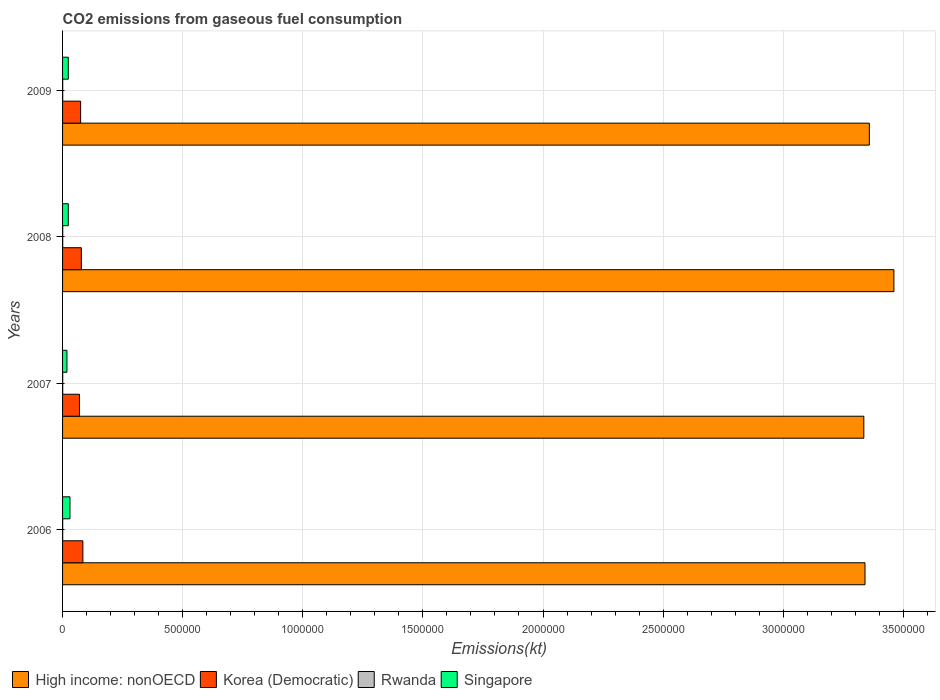How many groups of bars are there?
Keep it short and to the point. 4. Are the number of bars per tick equal to the number of legend labels?
Offer a terse response. Yes. Are the number of bars on each tick of the Y-axis equal?
Ensure brevity in your answer.  Yes. How many bars are there on the 2nd tick from the bottom?
Offer a very short reply. 4. What is the label of the 2nd group of bars from the top?
Your response must be concise. 2008. In how many cases, is the number of bars for a given year not equal to the number of legend labels?
Offer a very short reply. 0. What is the amount of CO2 emitted in Korea (Democratic) in 2006?
Offer a very short reply. 8.46e+04. Across all years, what is the maximum amount of CO2 emitted in Korea (Democratic)?
Offer a terse response. 8.46e+04. Across all years, what is the minimum amount of CO2 emitted in High income: nonOECD?
Offer a terse response. 3.34e+06. In which year was the amount of CO2 emitted in High income: nonOECD maximum?
Keep it short and to the point. 2008. In which year was the amount of CO2 emitted in Korea (Democratic) minimum?
Keep it short and to the point. 2007. What is the total amount of CO2 emitted in Korea (Democratic) in the graph?
Provide a short and direct response. 3.08e+05. What is the difference between the amount of CO2 emitted in High income: nonOECD in 2006 and that in 2008?
Your answer should be very brief. -1.20e+05. What is the difference between the amount of CO2 emitted in Rwanda in 2009 and the amount of CO2 emitted in High income: nonOECD in 2007?
Your response must be concise. -3.34e+06. What is the average amount of CO2 emitted in High income: nonOECD per year?
Your answer should be very brief. 3.37e+06. In the year 2009, what is the difference between the amount of CO2 emitted in Korea (Democratic) and amount of CO2 emitted in Rwanda?
Ensure brevity in your answer.  7.47e+04. In how many years, is the amount of CO2 emitted in Singapore greater than 1500000 kt?
Your answer should be very brief. 0. What is the ratio of the amount of CO2 emitted in High income: nonOECD in 2007 to that in 2008?
Offer a terse response. 0.96. Is the amount of CO2 emitted in Korea (Democratic) in 2008 less than that in 2009?
Provide a short and direct response. No. Is the difference between the amount of CO2 emitted in Korea (Democratic) in 2007 and 2009 greater than the difference between the amount of CO2 emitted in Rwanda in 2007 and 2009?
Your response must be concise. No. What is the difference between the highest and the second highest amount of CO2 emitted in Singapore?
Keep it short and to the point. 6952.63. What is the difference between the highest and the lowest amount of CO2 emitted in Rwanda?
Keep it short and to the point. 47.67. Is it the case that in every year, the sum of the amount of CO2 emitted in Singapore and amount of CO2 emitted in Rwanda is greater than the sum of amount of CO2 emitted in High income: nonOECD and amount of CO2 emitted in Korea (Democratic)?
Provide a succinct answer. Yes. What does the 2nd bar from the top in 2009 represents?
Your response must be concise. Rwanda. What does the 2nd bar from the bottom in 2007 represents?
Make the answer very short. Korea (Democratic). Is it the case that in every year, the sum of the amount of CO2 emitted in Rwanda and amount of CO2 emitted in Korea (Democratic) is greater than the amount of CO2 emitted in Singapore?
Offer a very short reply. Yes. How many bars are there?
Ensure brevity in your answer.  16. Are all the bars in the graph horizontal?
Your answer should be very brief. Yes. How many years are there in the graph?
Offer a terse response. 4. What is the difference between two consecutive major ticks on the X-axis?
Offer a very short reply. 5.00e+05. Are the values on the major ticks of X-axis written in scientific E-notation?
Offer a very short reply. No. Does the graph contain any zero values?
Ensure brevity in your answer.  No. Does the graph contain grids?
Provide a succinct answer. Yes. Where does the legend appear in the graph?
Provide a short and direct response. Bottom left. What is the title of the graph?
Your answer should be compact. CO2 emissions from gaseous fuel consumption. What is the label or title of the X-axis?
Provide a short and direct response. Emissions(kt). What is the label or title of the Y-axis?
Your response must be concise. Years. What is the Emissions(kt) of High income: nonOECD in 2006?
Your response must be concise. 3.34e+06. What is the Emissions(kt) of Korea (Democratic) in 2006?
Your response must be concise. 8.46e+04. What is the Emissions(kt) in Rwanda in 2006?
Provide a short and direct response. 528.05. What is the Emissions(kt) in Singapore in 2006?
Your answer should be very brief. 3.08e+04. What is the Emissions(kt) in High income: nonOECD in 2007?
Offer a very short reply. 3.34e+06. What is the Emissions(kt) of Korea (Democratic) in 2007?
Make the answer very short. 7.04e+04. What is the Emissions(kt) of Rwanda in 2007?
Offer a terse response. 557.38. What is the Emissions(kt) of Singapore in 2007?
Offer a terse response. 1.82e+04. What is the Emissions(kt) in High income: nonOECD in 2008?
Provide a succinct answer. 3.46e+06. What is the Emissions(kt) of Korea (Democratic) in 2008?
Your response must be concise. 7.81e+04. What is the Emissions(kt) in Rwanda in 2008?
Offer a very short reply. 542.72. What is the Emissions(kt) of Singapore in 2008?
Offer a very short reply. 2.38e+04. What is the Emissions(kt) in High income: nonOECD in 2009?
Your answer should be very brief. 3.36e+06. What is the Emissions(kt) of Korea (Democratic) in 2009?
Your answer should be very brief. 7.52e+04. What is the Emissions(kt) of Rwanda in 2009?
Give a very brief answer. 575.72. What is the Emissions(kt) of Singapore in 2009?
Provide a short and direct response. 2.38e+04. Across all years, what is the maximum Emissions(kt) of High income: nonOECD?
Offer a very short reply. 3.46e+06. Across all years, what is the maximum Emissions(kt) of Korea (Democratic)?
Ensure brevity in your answer.  8.46e+04. Across all years, what is the maximum Emissions(kt) in Rwanda?
Make the answer very short. 575.72. Across all years, what is the maximum Emissions(kt) of Singapore?
Give a very brief answer. 3.08e+04. Across all years, what is the minimum Emissions(kt) in High income: nonOECD?
Keep it short and to the point. 3.34e+06. Across all years, what is the minimum Emissions(kt) of Korea (Democratic)?
Keep it short and to the point. 7.04e+04. Across all years, what is the minimum Emissions(kt) of Rwanda?
Ensure brevity in your answer.  528.05. Across all years, what is the minimum Emissions(kt) in Singapore?
Provide a succinct answer. 1.82e+04. What is the total Emissions(kt) in High income: nonOECD in the graph?
Provide a succinct answer. 1.35e+07. What is the total Emissions(kt) in Korea (Democratic) in the graph?
Your answer should be very brief. 3.08e+05. What is the total Emissions(kt) of Rwanda in the graph?
Offer a very short reply. 2203.87. What is the total Emissions(kt) of Singapore in the graph?
Your answer should be compact. 9.67e+04. What is the difference between the Emissions(kt) in High income: nonOECD in 2006 and that in 2007?
Make the answer very short. 4914.35. What is the difference between the Emissions(kt) of Korea (Democratic) in 2006 and that in 2007?
Keep it short and to the point. 1.42e+04. What is the difference between the Emissions(kt) in Rwanda in 2006 and that in 2007?
Your answer should be compact. -29.34. What is the difference between the Emissions(kt) in Singapore in 2006 and that in 2007?
Make the answer very short. 1.26e+04. What is the difference between the Emissions(kt) in High income: nonOECD in 2006 and that in 2008?
Your answer should be compact. -1.20e+05. What is the difference between the Emissions(kt) of Korea (Democratic) in 2006 and that in 2008?
Your answer should be very brief. 6475.92. What is the difference between the Emissions(kt) in Rwanda in 2006 and that in 2008?
Provide a succinct answer. -14.67. What is the difference between the Emissions(kt) in Singapore in 2006 and that in 2008?
Keep it short and to the point. 6952.63. What is the difference between the Emissions(kt) of High income: nonOECD in 2006 and that in 2009?
Provide a short and direct response. -1.81e+04. What is the difference between the Emissions(kt) in Korea (Democratic) in 2006 and that in 2009?
Your answer should be compact. 9328.85. What is the difference between the Emissions(kt) in Rwanda in 2006 and that in 2009?
Provide a short and direct response. -47.67. What is the difference between the Emissions(kt) of Singapore in 2006 and that in 2009?
Ensure brevity in your answer.  6967.3. What is the difference between the Emissions(kt) of High income: nonOECD in 2007 and that in 2008?
Provide a short and direct response. -1.25e+05. What is the difference between the Emissions(kt) of Korea (Democratic) in 2007 and that in 2008?
Provide a succinct answer. -7711.7. What is the difference between the Emissions(kt) in Rwanda in 2007 and that in 2008?
Offer a terse response. 14.67. What is the difference between the Emissions(kt) of Singapore in 2007 and that in 2008?
Provide a short and direct response. -5650.85. What is the difference between the Emissions(kt) in High income: nonOECD in 2007 and that in 2009?
Offer a terse response. -2.30e+04. What is the difference between the Emissions(kt) in Korea (Democratic) in 2007 and that in 2009?
Your answer should be very brief. -4858.77. What is the difference between the Emissions(kt) of Rwanda in 2007 and that in 2009?
Provide a succinct answer. -18.34. What is the difference between the Emissions(kt) of Singapore in 2007 and that in 2009?
Offer a terse response. -5636.18. What is the difference between the Emissions(kt) in High income: nonOECD in 2008 and that in 2009?
Your answer should be compact. 1.02e+05. What is the difference between the Emissions(kt) in Korea (Democratic) in 2008 and that in 2009?
Make the answer very short. 2852.93. What is the difference between the Emissions(kt) of Rwanda in 2008 and that in 2009?
Your response must be concise. -33. What is the difference between the Emissions(kt) of Singapore in 2008 and that in 2009?
Your answer should be very brief. 14.67. What is the difference between the Emissions(kt) of High income: nonOECD in 2006 and the Emissions(kt) of Korea (Democratic) in 2007?
Offer a very short reply. 3.27e+06. What is the difference between the Emissions(kt) of High income: nonOECD in 2006 and the Emissions(kt) of Rwanda in 2007?
Offer a terse response. 3.34e+06. What is the difference between the Emissions(kt) in High income: nonOECD in 2006 and the Emissions(kt) in Singapore in 2007?
Keep it short and to the point. 3.32e+06. What is the difference between the Emissions(kt) of Korea (Democratic) in 2006 and the Emissions(kt) of Rwanda in 2007?
Provide a short and direct response. 8.40e+04. What is the difference between the Emissions(kt) of Korea (Democratic) in 2006 and the Emissions(kt) of Singapore in 2007?
Offer a terse response. 6.64e+04. What is the difference between the Emissions(kt) in Rwanda in 2006 and the Emissions(kt) in Singapore in 2007?
Provide a short and direct response. -1.77e+04. What is the difference between the Emissions(kt) of High income: nonOECD in 2006 and the Emissions(kt) of Korea (Democratic) in 2008?
Ensure brevity in your answer.  3.26e+06. What is the difference between the Emissions(kt) of High income: nonOECD in 2006 and the Emissions(kt) of Rwanda in 2008?
Your answer should be very brief. 3.34e+06. What is the difference between the Emissions(kt) in High income: nonOECD in 2006 and the Emissions(kt) in Singapore in 2008?
Your response must be concise. 3.32e+06. What is the difference between the Emissions(kt) of Korea (Democratic) in 2006 and the Emissions(kt) of Rwanda in 2008?
Provide a succinct answer. 8.40e+04. What is the difference between the Emissions(kt) of Korea (Democratic) in 2006 and the Emissions(kt) of Singapore in 2008?
Provide a short and direct response. 6.07e+04. What is the difference between the Emissions(kt) of Rwanda in 2006 and the Emissions(kt) of Singapore in 2008?
Provide a succinct answer. -2.33e+04. What is the difference between the Emissions(kt) in High income: nonOECD in 2006 and the Emissions(kt) in Korea (Democratic) in 2009?
Your response must be concise. 3.27e+06. What is the difference between the Emissions(kt) of High income: nonOECD in 2006 and the Emissions(kt) of Rwanda in 2009?
Provide a short and direct response. 3.34e+06. What is the difference between the Emissions(kt) of High income: nonOECD in 2006 and the Emissions(kt) of Singapore in 2009?
Give a very brief answer. 3.32e+06. What is the difference between the Emissions(kt) of Korea (Democratic) in 2006 and the Emissions(kt) of Rwanda in 2009?
Offer a very short reply. 8.40e+04. What is the difference between the Emissions(kt) of Korea (Democratic) in 2006 and the Emissions(kt) of Singapore in 2009?
Offer a terse response. 6.07e+04. What is the difference between the Emissions(kt) in Rwanda in 2006 and the Emissions(kt) in Singapore in 2009?
Offer a terse response. -2.33e+04. What is the difference between the Emissions(kt) in High income: nonOECD in 2007 and the Emissions(kt) in Korea (Democratic) in 2008?
Your answer should be very brief. 3.26e+06. What is the difference between the Emissions(kt) of High income: nonOECD in 2007 and the Emissions(kt) of Rwanda in 2008?
Ensure brevity in your answer.  3.34e+06. What is the difference between the Emissions(kt) in High income: nonOECD in 2007 and the Emissions(kt) in Singapore in 2008?
Your answer should be very brief. 3.31e+06. What is the difference between the Emissions(kt) in Korea (Democratic) in 2007 and the Emissions(kt) in Rwanda in 2008?
Give a very brief answer. 6.98e+04. What is the difference between the Emissions(kt) of Korea (Democratic) in 2007 and the Emissions(kt) of Singapore in 2008?
Your answer should be compact. 4.65e+04. What is the difference between the Emissions(kt) of Rwanda in 2007 and the Emissions(kt) of Singapore in 2008?
Your response must be concise. -2.33e+04. What is the difference between the Emissions(kt) of High income: nonOECD in 2007 and the Emissions(kt) of Korea (Democratic) in 2009?
Your response must be concise. 3.26e+06. What is the difference between the Emissions(kt) of High income: nonOECD in 2007 and the Emissions(kt) of Rwanda in 2009?
Provide a short and direct response. 3.34e+06. What is the difference between the Emissions(kt) in High income: nonOECD in 2007 and the Emissions(kt) in Singapore in 2009?
Provide a short and direct response. 3.31e+06. What is the difference between the Emissions(kt) of Korea (Democratic) in 2007 and the Emissions(kt) of Rwanda in 2009?
Provide a succinct answer. 6.98e+04. What is the difference between the Emissions(kt) in Korea (Democratic) in 2007 and the Emissions(kt) in Singapore in 2009?
Keep it short and to the point. 4.65e+04. What is the difference between the Emissions(kt) in Rwanda in 2007 and the Emissions(kt) in Singapore in 2009?
Offer a very short reply. -2.33e+04. What is the difference between the Emissions(kt) of High income: nonOECD in 2008 and the Emissions(kt) of Korea (Democratic) in 2009?
Provide a succinct answer. 3.39e+06. What is the difference between the Emissions(kt) in High income: nonOECD in 2008 and the Emissions(kt) in Rwanda in 2009?
Offer a terse response. 3.46e+06. What is the difference between the Emissions(kt) of High income: nonOECD in 2008 and the Emissions(kt) of Singapore in 2009?
Your answer should be very brief. 3.44e+06. What is the difference between the Emissions(kt) in Korea (Democratic) in 2008 and the Emissions(kt) in Rwanda in 2009?
Ensure brevity in your answer.  7.75e+04. What is the difference between the Emissions(kt) in Korea (Democratic) in 2008 and the Emissions(kt) in Singapore in 2009?
Offer a very short reply. 5.42e+04. What is the difference between the Emissions(kt) of Rwanda in 2008 and the Emissions(kt) of Singapore in 2009?
Your response must be concise. -2.33e+04. What is the average Emissions(kt) of High income: nonOECD per year?
Offer a terse response. 3.37e+06. What is the average Emissions(kt) of Korea (Democratic) per year?
Provide a succinct answer. 7.71e+04. What is the average Emissions(kt) in Rwanda per year?
Ensure brevity in your answer.  550.97. What is the average Emissions(kt) in Singapore per year?
Keep it short and to the point. 2.42e+04. In the year 2006, what is the difference between the Emissions(kt) in High income: nonOECD and Emissions(kt) in Korea (Democratic)?
Your response must be concise. 3.26e+06. In the year 2006, what is the difference between the Emissions(kt) in High income: nonOECD and Emissions(kt) in Rwanda?
Your answer should be very brief. 3.34e+06. In the year 2006, what is the difference between the Emissions(kt) of High income: nonOECD and Emissions(kt) of Singapore?
Your answer should be very brief. 3.31e+06. In the year 2006, what is the difference between the Emissions(kt) of Korea (Democratic) and Emissions(kt) of Rwanda?
Offer a very short reply. 8.40e+04. In the year 2006, what is the difference between the Emissions(kt) of Korea (Democratic) and Emissions(kt) of Singapore?
Offer a terse response. 5.38e+04. In the year 2006, what is the difference between the Emissions(kt) of Rwanda and Emissions(kt) of Singapore?
Your response must be concise. -3.03e+04. In the year 2007, what is the difference between the Emissions(kt) of High income: nonOECD and Emissions(kt) of Korea (Democratic)?
Offer a very short reply. 3.27e+06. In the year 2007, what is the difference between the Emissions(kt) in High income: nonOECD and Emissions(kt) in Rwanda?
Provide a succinct answer. 3.34e+06. In the year 2007, what is the difference between the Emissions(kt) in High income: nonOECD and Emissions(kt) in Singapore?
Provide a short and direct response. 3.32e+06. In the year 2007, what is the difference between the Emissions(kt) in Korea (Democratic) and Emissions(kt) in Rwanda?
Your answer should be very brief. 6.98e+04. In the year 2007, what is the difference between the Emissions(kt) of Korea (Democratic) and Emissions(kt) of Singapore?
Your answer should be very brief. 5.22e+04. In the year 2007, what is the difference between the Emissions(kt) in Rwanda and Emissions(kt) in Singapore?
Your answer should be very brief. -1.76e+04. In the year 2008, what is the difference between the Emissions(kt) in High income: nonOECD and Emissions(kt) in Korea (Democratic)?
Offer a terse response. 3.38e+06. In the year 2008, what is the difference between the Emissions(kt) of High income: nonOECD and Emissions(kt) of Rwanda?
Offer a very short reply. 3.46e+06. In the year 2008, what is the difference between the Emissions(kt) in High income: nonOECD and Emissions(kt) in Singapore?
Offer a terse response. 3.44e+06. In the year 2008, what is the difference between the Emissions(kt) in Korea (Democratic) and Emissions(kt) in Rwanda?
Provide a short and direct response. 7.75e+04. In the year 2008, what is the difference between the Emissions(kt) in Korea (Democratic) and Emissions(kt) in Singapore?
Provide a short and direct response. 5.42e+04. In the year 2008, what is the difference between the Emissions(kt) in Rwanda and Emissions(kt) in Singapore?
Provide a succinct answer. -2.33e+04. In the year 2009, what is the difference between the Emissions(kt) in High income: nonOECD and Emissions(kt) in Korea (Democratic)?
Provide a succinct answer. 3.28e+06. In the year 2009, what is the difference between the Emissions(kt) of High income: nonOECD and Emissions(kt) of Rwanda?
Offer a terse response. 3.36e+06. In the year 2009, what is the difference between the Emissions(kt) in High income: nonOECD and Emissions(kt) in Singapore?
Provide a succinct answer. 3.33e+06. In the year 2009, what is the difference between the Emissions(kt) in Korea (Democratic) and Emissions(kt) in Rwanda?
Provide a succinct answer. 7.47e+04. In the year 2009, what is the difference between the Emissions(kt) of Korea (Democratic) and Emissions(kt) of Singapore?
Your answer should be compact. 5.14e+04. In the year 2009, what is the difference between the Emissions(kt) of Rwanda and Emissions(kt) of Singapore?
Offer a terse response. -2.33e+04. What is the ratio of the Emissions(kt) of High income: nonOECD in 2006 to that in 2007?
Keep it short and to the point. 1. What is the ratio of the Emissions(kt) of Korea (Democratic) in 2006 to that in 2007?
Your answer should be compact. 1.2. What is the ratio of the Emissions(kt) of Rwanda in 2006 to that in 2007?
Your answer should be compact. 0.95. What is the ratio of the Emissions(kt) in Singapore in 2006 to that in 2007?
Ensure brevity in your answer.  1.69. What is the ratio of the Emissions(kt) of High income: nonOECD in 2006 to that in 2008?
Offer a terse response. 0.97. What is the ratio of the Emissions(kt) in Korea (Democratic) in 2006 to that in 2008?
Ensure brevity in your answer.  1.08. What is the ratio of the Emissions(kt) of Rwanda in 2006 to that in 2008?
Provide a short and direct response. 0.97. What is the ratio of the Emissions(kt) of Singapore in 2006 to that in 2008?
Your answer should be compact. 1.29. What is the ratio of the Emissions(kt) of Korea (Democratic) in 2006 to that in 2009?
Your answer should be very brief. 1.12. What is the ratio of the Emissions(kt) in Rwanda in 2006 to that in 2009?
Your response must be concise. 0.92. What is the ratio of the Emissions(kt) in Singapore in 2006 to that in 2009?
Keep it short and to the point. 1.29. What is the ratio of the Emissions(kt) in High income: nonOECD in 2007 to that in 2008?
Ensure brevity in your answer.  0.96. What is the ratio of the Emissions(kt) of Korea (Democratic) in 2007 to that in 2008?
Provide a succinct answer. 0.9. What is the ratio of the Emissions(kt) in Singapore in 2007 to that in 2008?
Your response must be concise. 0.76. What is the ratio of the Emissions(kt) in High income: nonOECD in 2007 to that in 2009?
Offer a very short reply. 0.99. What is the ratio of the Emissions(kt) of Korea (Democratic) in 2007 to that in 2009?
Offer a very short reply. 0.94. What is the ratio of the Emissions(kt) in Rwanda in 2007 to that in 2009?
Ensure brevity in your answer.  0.97. What is the ratio of the Emissions(kt) in Singapore in 2007 to that in 2009?
Your response must be concise. 0.76. What is the ratio of the Emissions(kt) of High income: nonOECD in 2008 to that in 2009?
Provide a succinct answer. 1.03. What is the ratio of the Emissions(kt) in Korea (Democratic) in 2008 to that in 2009?
Give a very brief answer. 1.04. What is the ratio of the Emissions(kt) of Rwanda in 2008 to that in 2009?
Your response must be concise. 0.94. What is the difference between the highest and the second highest Emissions(kt) in High income: nonOECD?
Your answer should be very brief. 1.02e+05. What is the difference between the highest and the second highest Emissions(kt) of Korea (Democratic)?
Provide a succinct answer. 6475.92. What is the difference between the highest and the second highest Emissions(kt) in Rwanda?
Provide a short and direct response. 18.34. What is the difference between the highest and the second highest Emissions(kt) in Singapore?
Provide a short and direct response. 6952.63. What is the difference between the highest and the lowest Emissions(kt) of High income: nonOECD?
Your answer should be compact. 1.25e+05. What is the difference between the highest and the lowest Emissions(kt) of Korea (Democratic)?
Offer a very short reply. 1.42e+04. What is the difference between the highest and the lowest Emissions(kt) of Rwanda?
Your answer should be very brief. 47.67. What is the difference between the highest and the lowest Emissions(kt) in Singapore?
Provide a short and direct response. 1.26e+04. 